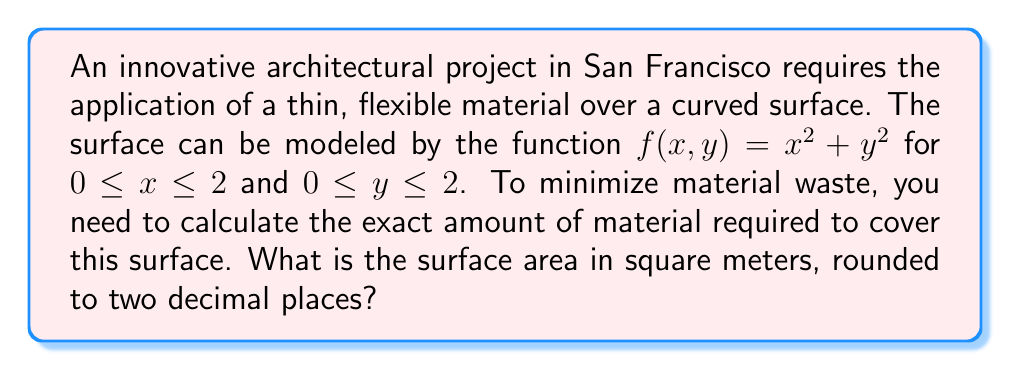Give your solution to this math problem. To solve this problem, we need to use the surface area formula for a parametric surface. The steps are as follows:

1) First, we identify that the surface is given by $z = f(x,y) = x^2 + y^2$.

2) The surface area formula for a function $z = f(x,y)$ over a region $R$ is:

   $$A = \iint_R \sqrt{1 + \left(\frac{\partial f}{\partial x}\right)^2 + \left(\frac{\partial f}{\partial y}\right)^2} \, dA$$

3) We need to calculate the partial derivatives:
   
   $\frac{\partial f}{\partial x} = 2x$
   $\frac{\partial f}{\partial y} = 2y$

4) Substituting these into our formula:

   $$A = \int_0^2 \int_0^2 \sqrt{1 + (2x)^2 + (2y)^2} \, dy \, dx$$

5) Simplify under the square root:

   $$A = \int_0^2 \int_0^2 \sqrt{1 + 4x^2 + 4y^2} \, dy \, dx$$

6) This integral is difficult to evaluate analytically. We'll need to use numerical integration methods, which are often employed in architectural and engineering applications for complex surfaces.

7) Using a numerical integration method (like Simpson's rule or a computer algebra system), we can evaluate this double integral.

8) The result of this numerical integration is approximately 11.4631 square meters.

9) Rounding to two decimal places gives us 11.46 square meters.

This calculation provides the exact amount of material needed to cover the curved surface, allowing for efficient material use in the construction project.
Answer: 11.46 square meters 